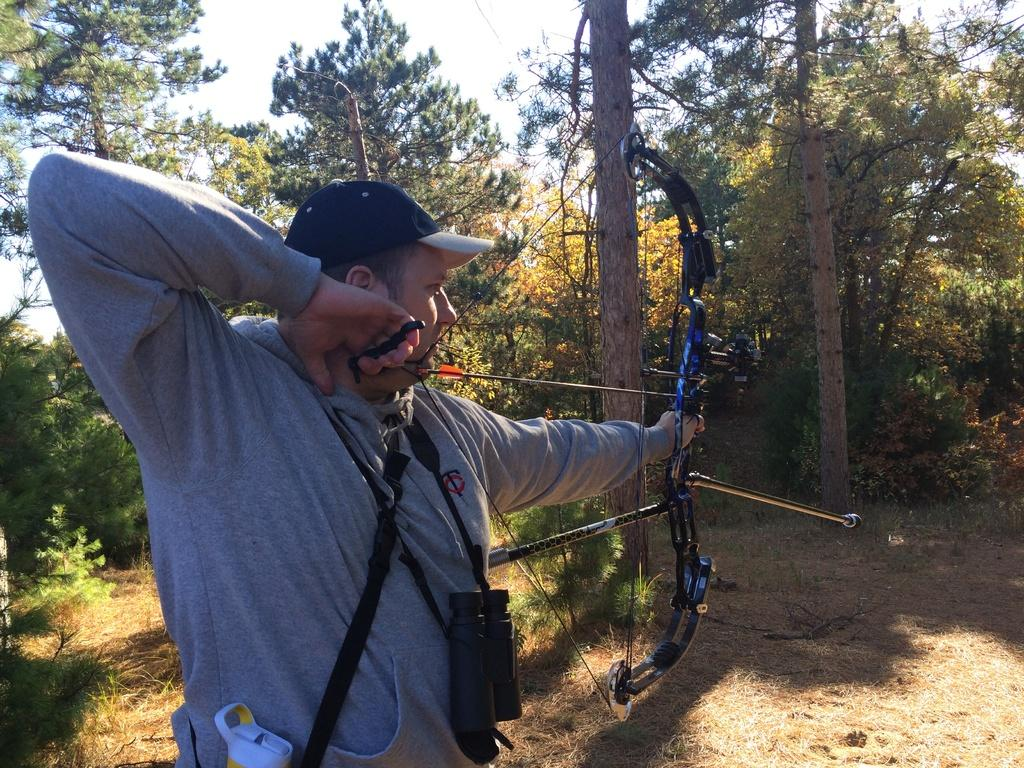What activity is the person in the image engaged in? The person in the image is playing archery. Can you describe the person wearing a camera in the image? There is a person wearing a camera in the image. What type of natural environment is visible in the image? There are trees and plants in the image, indicating a natural environment. What is visible in the background of the image? The sky is visible in the image. Can you describe the object that appears to be truncated in the image? There is an object that appears to be truncated in the image, but its details cannot be determined from the provided facts. What type of basket is the person carrying in the image? There is no basket present in the image. Can you describe the vessel that the person is using to play the archery game in the image? There is no vessel used in the game of archery; the person is using a bow and arrow. What advice would the person's grandfather give them in the image? There is no grandfather present in the image, so it is not possible to determine what advice they might give. 